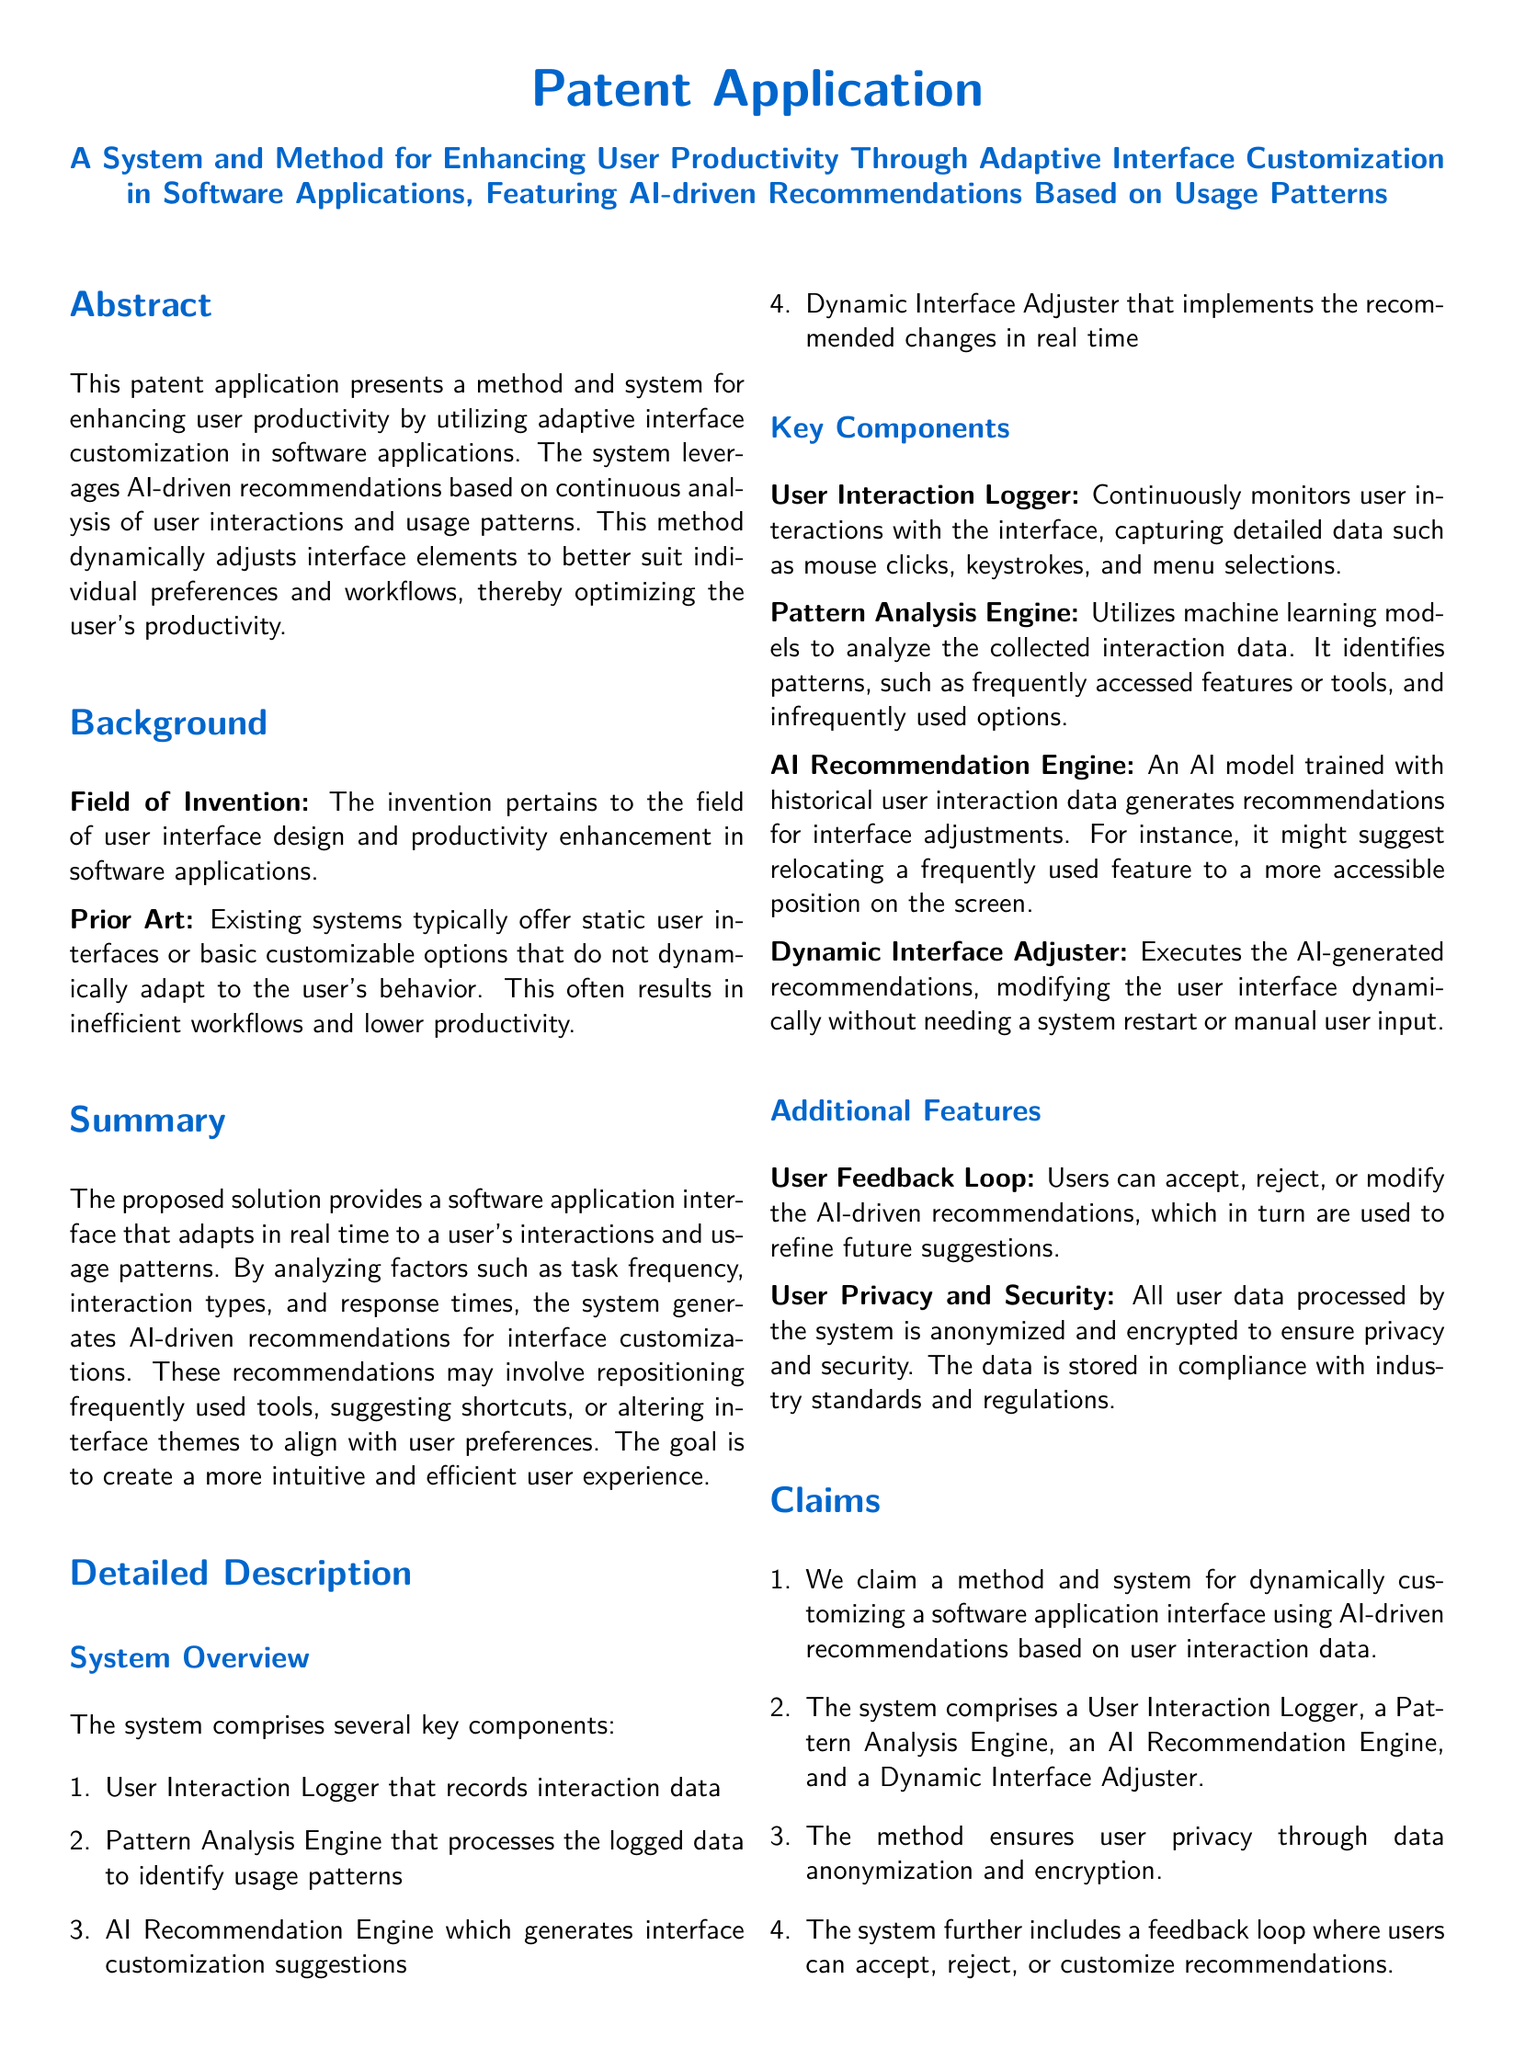What is the title of the patent application? The title of the patent application is stated in the document's heading.
Answer: A System and Method for Enhancing User Productivity Through Adaptive Interface Customization in Software Applications, Featuring AI-driven Recommendations Based on Usage Patterns What is the primary purpose of the system described? The abstract outlines the primary purpose of the system, which is to enhance user productivity.
Answer: Enhancing user productivity Name one of the key components of the system. The detailed description lists key components of the system.
Answer: User Interaction Logger What does the AI Recommendation Engine do? The detailed description explains the function of the AI Recommendation Engine.
Answer: Generates interface customization suggestions What feature ensures the privacy of user data? The additional features section mentions a specific feature related to user data.
Answer: User Privacy and Security How does the system adapt the interface? The summary describes how the interface is adapted based on user interactions.
Answer: By analyzing usage patterns What is the function of the Dynamic Interface Adjuster? The detailed description specifies the role of the Dynamic Interface Adjuster.
Answer: Implements the recommended changes in real time How can users provide feedback on AI recommendations? The additional features section mentions how users can interact with recommendations.
Answer: Users can accept, reject, or modify the AI-driven recommendations What compliance does the system ensure for data storage? The additional features section mentions regulatory compliance concerning user data.
Answer: Industry standards and regulations 